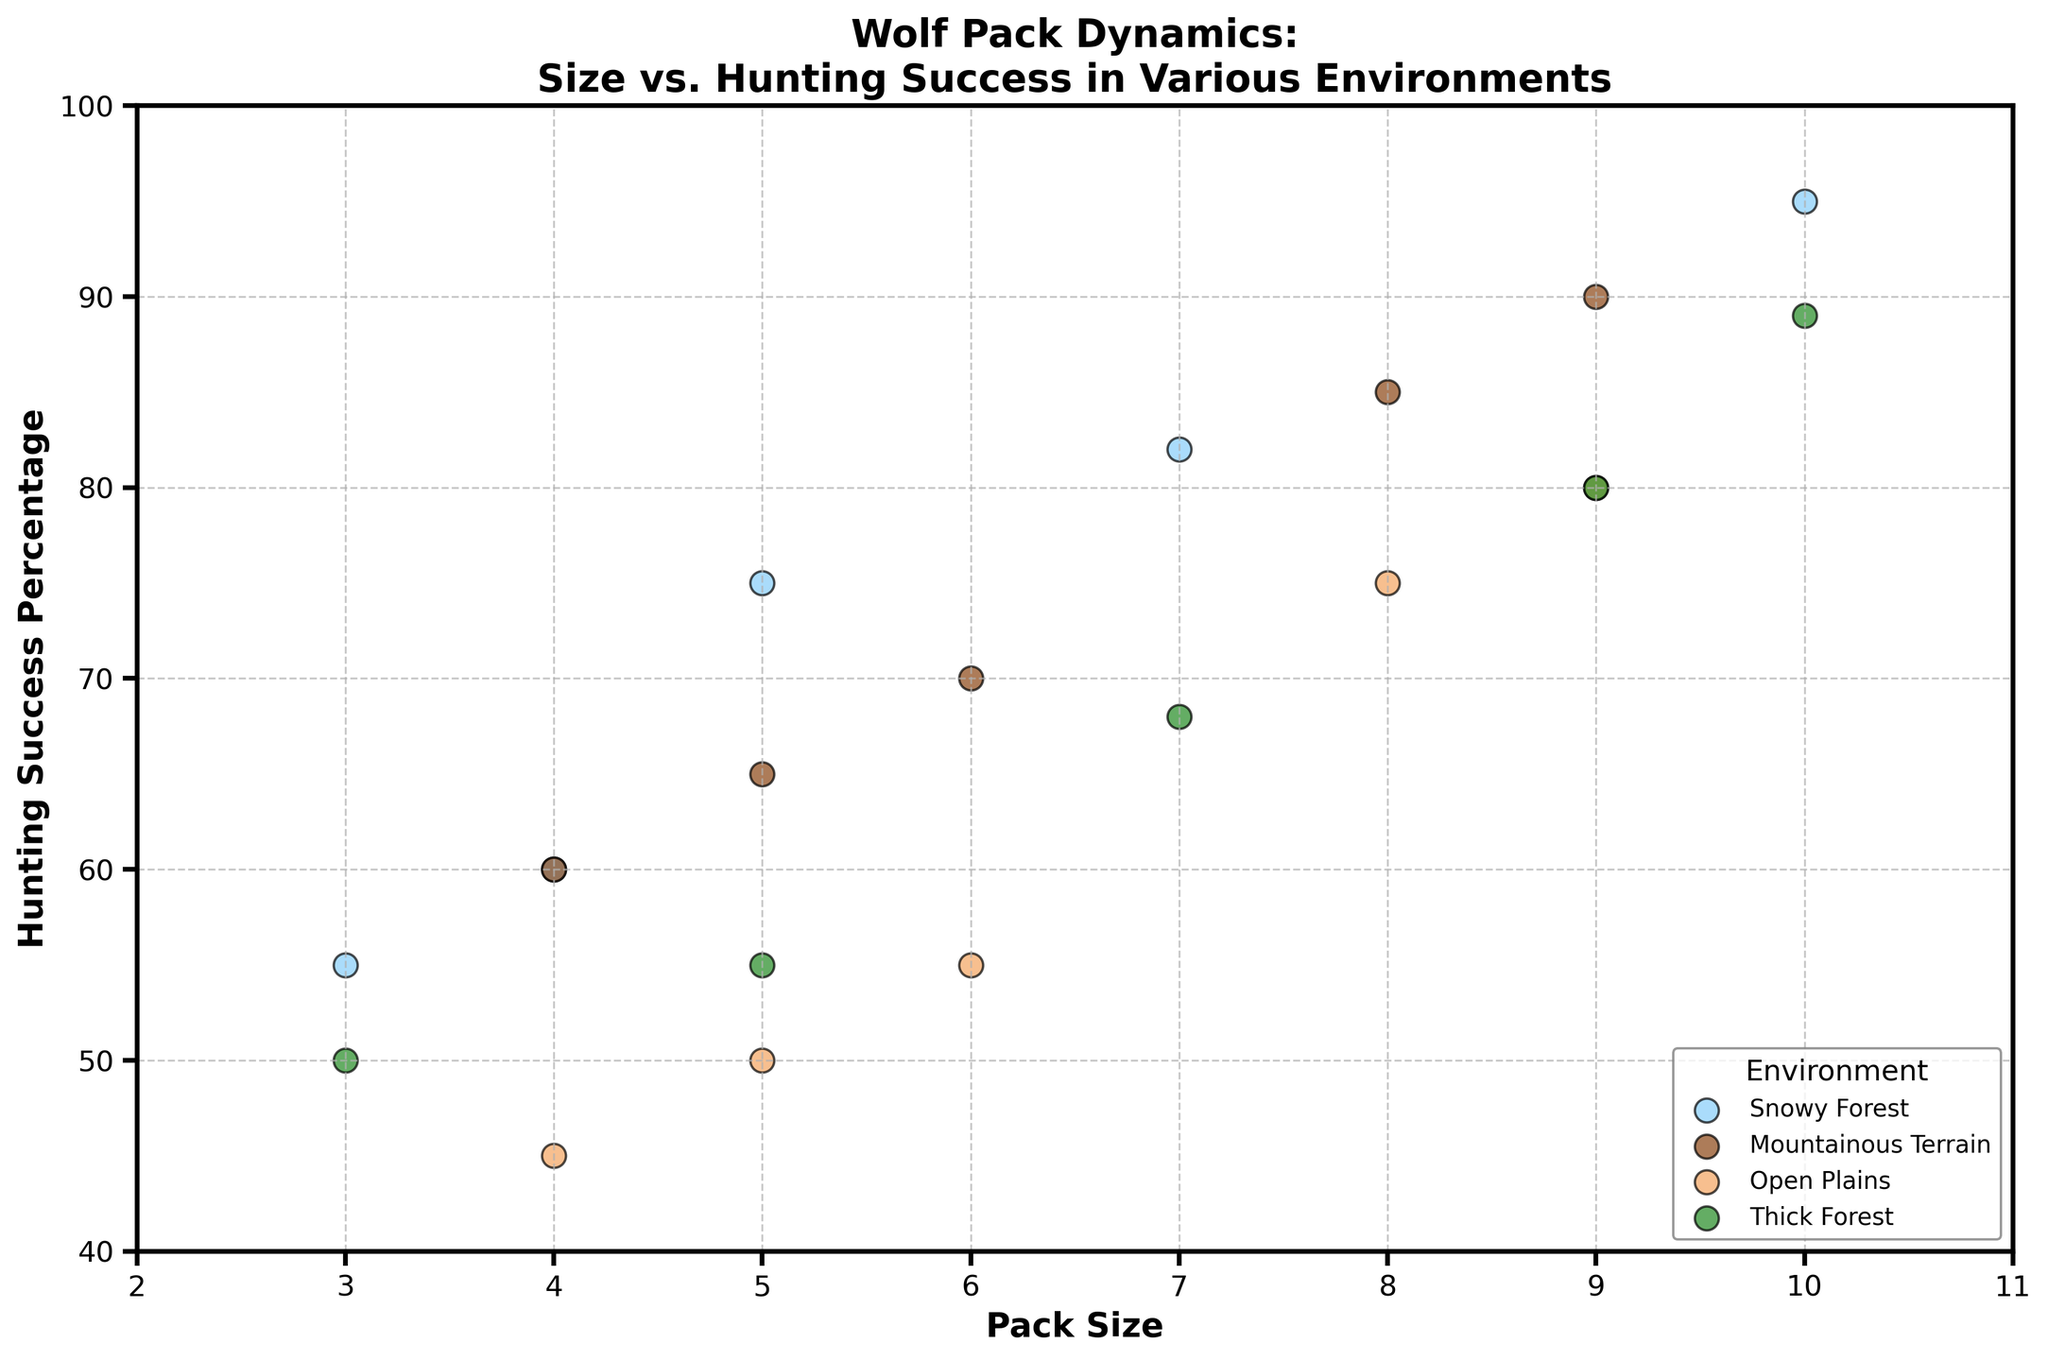What are the axes labeled in the plot? The x-axis is labeled "Pack Size" and the y-axis is labeled "Hunting Success Percentage".
Answer: Pack Size, Hunting Success Percentage What is the highest hunting success percentage for a pack in a Snowy Forest environment? The highest hunting success percentage for a pack in a Snowy Forest environment can be found at the point where the marker color represents Snowy Forest and the y-axis value is at its peak.
Answer: 95% What is the average pack size across all environments? Sum up all the pack sizes and divide by the total number of data points: (5+7+4+10+3+6+8+5+9+4+6+8+5+9+4+7+9+5+10+3)/20 = 150/20
Answer: 7.5 Which environment has the lowest hunting success percentage for a pack size of 4? Look for the pack size of 4 on the x-axis and identify the corresponding (y-axis) hunting success percentages across different environments. The lowest is 45% in Open Plains.
Answer: Open Plains (45%) Do larger packs generally have higher hunting success rates in a Mountainous Terrain? Compare the data points in Mountainous Terrain: Packs of sizes 8 and 9 show higher success rates (85% and 90%) compared to smaller pack sizes 6 and 5 (70% and 65%).
Answer: Yes What is the difference in hunting success percentage between the largest and smallest packs in a Thick Forest environment? Identify the successful hunting percentages for the largest pack (10, 89%) and the smallest pack (3, 50%), then subtract the smaller from the larger: 89% - 50%
Answer: 39% Which environment shows the most variability in hunting success based on pack size? Evaluate the spread of data points for each environment. Thick Forest shows a wide range from 50% to 89%.
Answer: Thick Forest Is there any environment where all packs have a hunting success percentage below 60%? Check the y-axis values for all environments; all present packs with hunting success above 60% at least in one data point.
Answer: No What pack size is most commonly associated with the highest hunting success (>90%)? Identify the pack sizes associated with data points where the hunting success is greater than 90%, which are mostly pack sizes 9 and 10.
Answer: 10 In which environment does the hunting success percentage increase sharply with increase in pack size, when pack size is exactly 5 to 10? Compare the slopes of hunting success percentages across pack sizes from 5 to 10 in each environment. The sharpest increase is in Snowy Forest.
Answer: Snowy Forest 